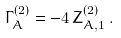<formula> <loc_0><loc_0><loc_500><loc_500>\Gamma _ { A } ^ { ( 2 ) } = - 4 \, Z _ { A , 1 } ^ { ( 2 ) } \, .</formula> 